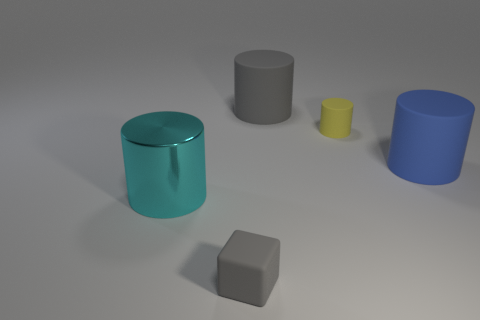Is the large gray matte object the same shape as the tiny yellow rubber thing?
Provide a succinct answer. Yes. Is there any other thing that has the same material as the yellow thing?
Ensure brevity in your answer.  Yes. Do the rubber thing on the right side of the tiny yellow cylinder and the gray thing that is in front of the big cyan shiny cylinder have the same size?
Your response must be concise. No. What is the material of the object that is both in front of the blue cylinder and behind the gray matte block?
Your answer should be compact. Metal. Is there any other thing of the same color as the small rubber cylinder?
Your answer should be compact. No. Is the number of yellow cylinders that are behind the large gray matte cylinder less than the number of large blue metal cubes?
Your response must be concise. No. Is the number of large objects greater than the number of large red matte things?
Your answer should be compact. Yes. Are there any small yellow cylinders behind the matte object left of the gray thing that is behind the metallic cylinder?
Make the answer very short. Yes. What number of other objects are there of the same size as the metal object?
Make the answer very short. 2. Are there any gray cylinders right of the big cyan metallic cylinder?
Keep it short and to the point. Yes. 